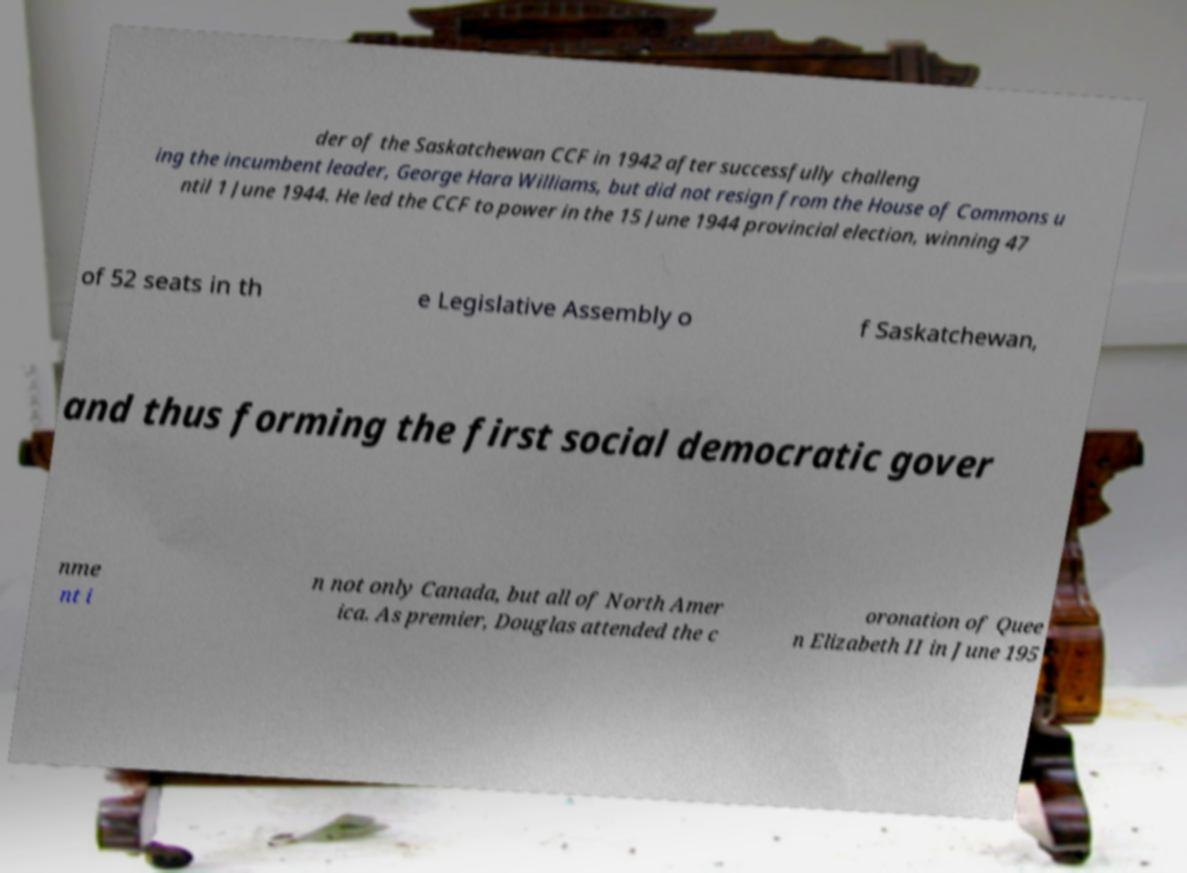Can you read and provide the text displayed in the image?This photo seems to have some interesting text. Can you extract and type it out for me? der of the Saskatchewan CCF in 1942 after successfully challeng ing the incumbent leader, George Hara Williams, but did not resign from the House of Commons u ntil 1 June 1944. He led the CCF to power in the 15 June 1944 provincial election, winning 47 of 52 seats in th e Legislative Assembly o f Saskatchewan, and thus forming the first social democratic gover nme nt i n not only Canada, but all of North Amer ica. As premier, Douglas attended the c oronation of Quee n Elizabeth II in June 195 